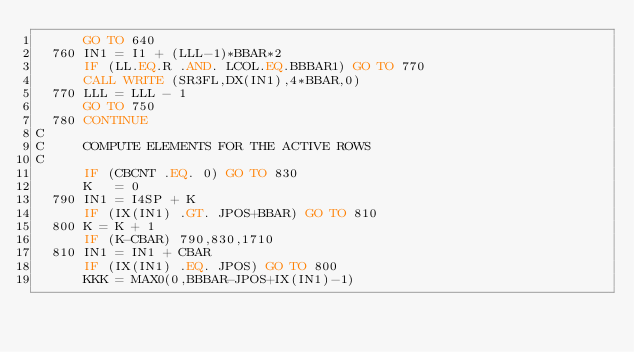Convert code to text. <code><loc_0><loc_0><loc_500><loc_500><_FORTRAN_>      GO TO 640
  760 IN1 = I1 + (LLL-1)*BBAR*2
      IF (LL.EQ.R .AND. LCOL.EQ.BBBAR1) GO TO 770
      CALL WRITE (SR3FL,DX(IN1),4*BBAR,0)
  770 LLL = LLL - 1
      GO TO 750
  780 CONTINUE
C
C     COMPUTE ELEMENTS FOR THE ACTIVE ROWS
C
      IF (CBCNT .EQ. 0) GO TO 830
      K   = 0
  790 IN1 = I4SP + K
      IF (IX(IN1) .GT. JPOS+BBAR) GO TO 810
  800 K = K + 1
      IF (K-CBAR) 790,830,1710
  810 IN1 = IN1 + CBAR
      IF (IX(IN1) .EQ. JPOS) GO TO 800
      KKK = MAX0(0,BBBAR-JPOS+IX(IN1)-1)</code> 